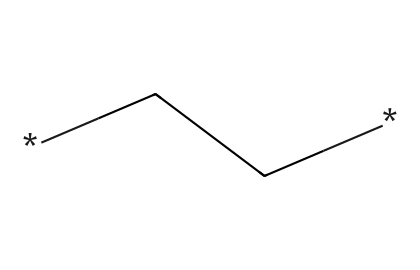What is the molecular formula of polyethylene represented in this structure? The SMILES representation *CC* indicates two carbon atoms connected by a single bond, which forms the backbone of polyethylene. Since each carbon can be bonded to enough hydrogen atoms to make a total of four bonds, each carbon in this case will have three hydrogen atoms. Therefore, the molecular formula is C2H4.
Answer: C2H4 How many carbon atoms are present in this molecule? The SMILES notation *CC* indicates two carbon atoms, as each 'C' represents one carbon atom. Counting them gives a total of two carbon atoms.
Answer: 2 What type of bonding occurs between the carbon atoms in polyethylene? The connection represented by *CC* demonstrates a single bond between the two carbon atoms, implying that the bond is a sigma bond which is characteristic of saturated hydrocarbons like polyethylene.
Answer: single bond What is the type of polymerization process involved in the formation of polyethylene? Polyethylene is formed through addition polymerization, where monomers like ethylene (C2H4) link together to form long chains without losing any atoms. The presence of double bonds in the monomer leads to the creation of a polymer by breaking those bonds during the polymerization.
Answer: addition polymerization How does the structure of polyethylene contribute to its physical properties? The straight-chain structure of polyethylene allows for close packing of polymer chains, which contributes to its strength and rigidity. Also, the saturation of bonds (single bonds) in polyethylene leads to a lower reactivity making it chemically stable. This contributes to properties such as tensile strength and resistance to environmental factors.
Answer: strength and rigidity What is the resulting form of polyethylene used in applications like legal document folders? The polymer chains of polyethylene are often processed into a film form which is flexible and durable, making it ideal for manufacturing items like legal document folders. The linearity and low density of the polyethylene allow it to be made thin and light while still providing adequate support.
Answer: film form 